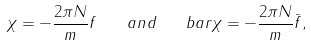Convert formula to latex. <formula><loc_0><loc_0><loc_500><loc_500>\chi = - \frac { 2 \pi N } { m } f \quad a n d \quad b a r \chi = - \frac { 2 \pi N } { m } \bar { f } ,</formula> 